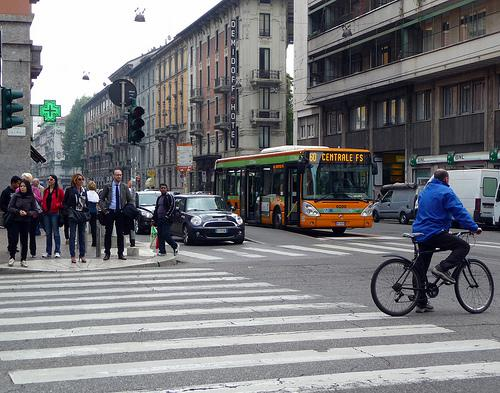Question: what number bus is it?
Choices:
A. 9.
B. 546.
C. 60.
D. 77.
Answer with the letter. Answer: C Question: where is the bus?
Choices:
A. The parking lot.
B. The bridge.
C. The tunnel.
D. The street.
Answer with the letter. Answer: D Question: who is on the bike?
Choices:
A. The woman.
B. The little boy.
C. The man.
D. The clown.
Answer with the letter. Answer: C Question: why is it so bright?
Choices:
A. It's midday.
B. All lights are on.
C. There is no shade.
D. Sunny.
Answer with the letter. Answer: D 